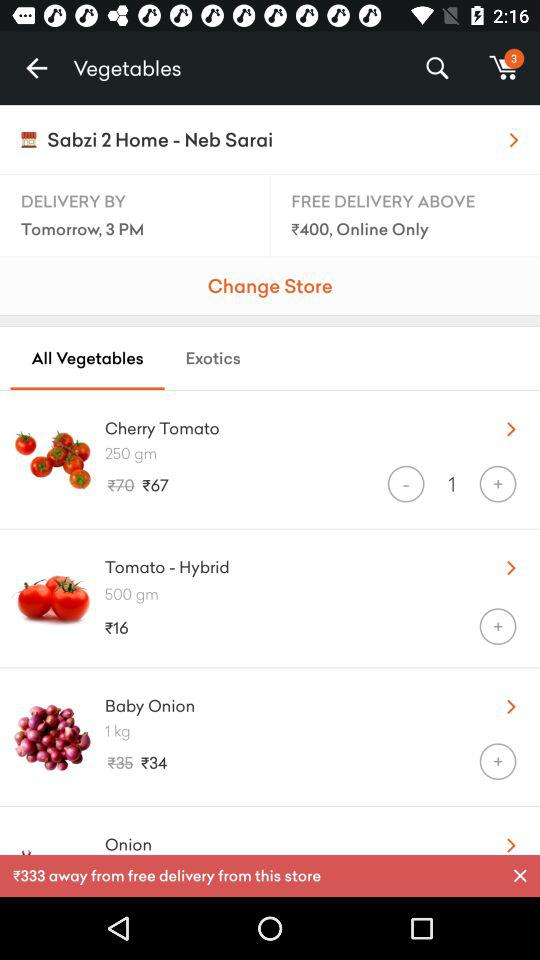What is the price of "Tomato - Hybrid"? The price of "Tomato - Hybrid" is 16 rupees. 